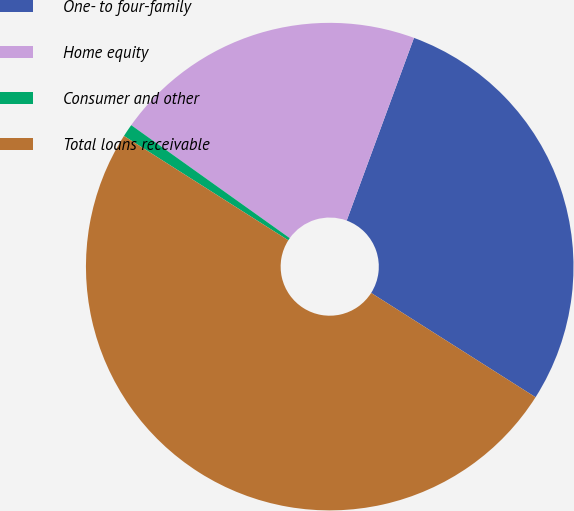<chart> <loc_0><loc_0><loc_500><loc_500><pie_chart><fcel>One- to four-family<fcel>Home equity<fcel>Consumer and other<fcel>Total loans receivable<nl><fcel>28.38%<fcel>20.76%<fcel>0.85%<fcel>50.0%<nl></chart> 